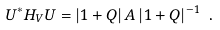<formula> <loc_0><loc_0><loc_500><loc_500>U ^ { * } H _ { V } U = | 1 + Q | \, A \, | 1 + Q | ^ { - 1 } \ .</formula> 